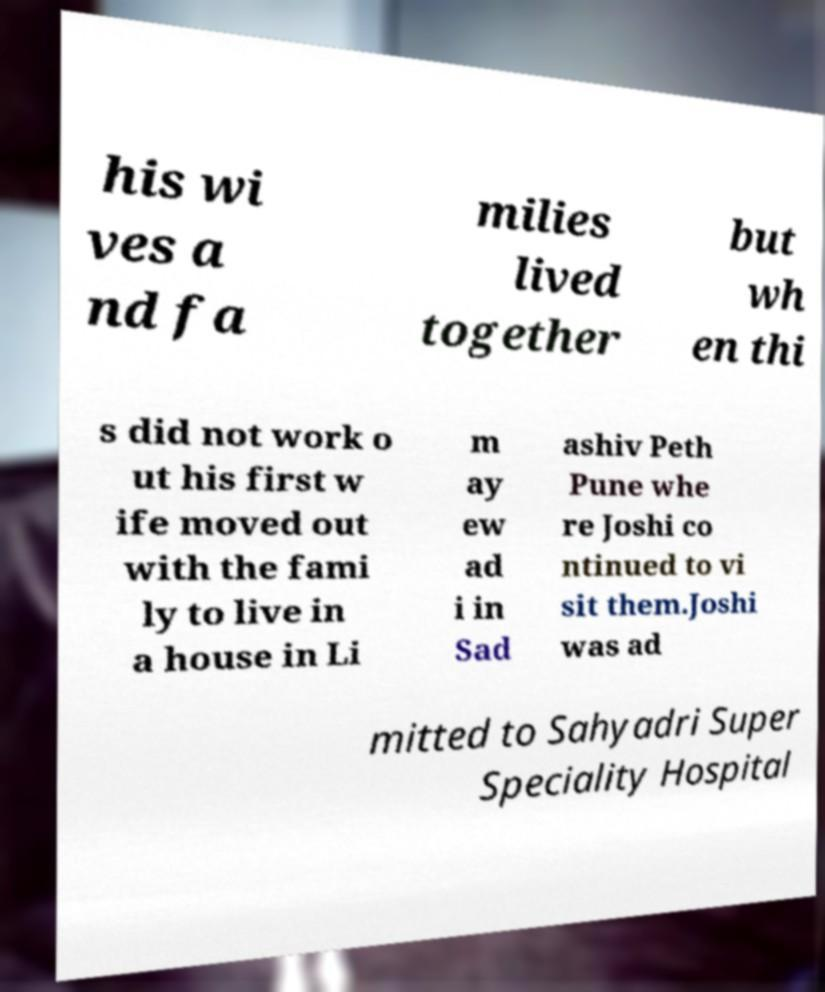I need the written content from this picture converted into text. Can you do that? his wi ves a nd fa milies lived together but wh en thi s did not work o ut his first w ife moved out with the fami ly to live in a house in Li m ay ew ad i in Sad ashiv Peth Pune whe re Joshi co ntinued to vi sit them.Joshi was ad mitted to Sahyadri Super Speciality Hospital 